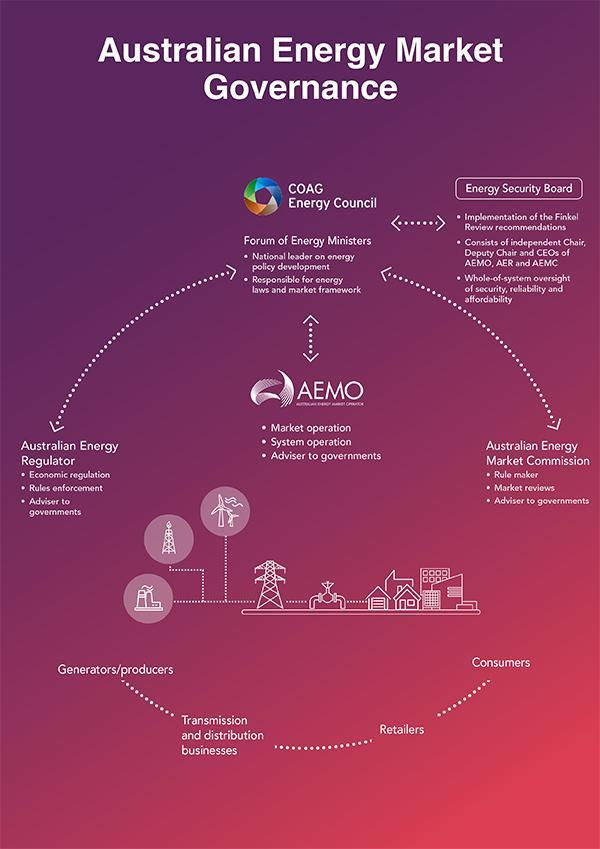Which authority act as the rule maker as per the flowchart?
Answer the question with a short phrase. Australian Energy Market Commission Which authority acts as an adviser to governments? Australian Energy Regulator Who is responsible for energy laws and market framework? Forum of Energy Ministers How many points comes under 'Energy Security Board'? 3 